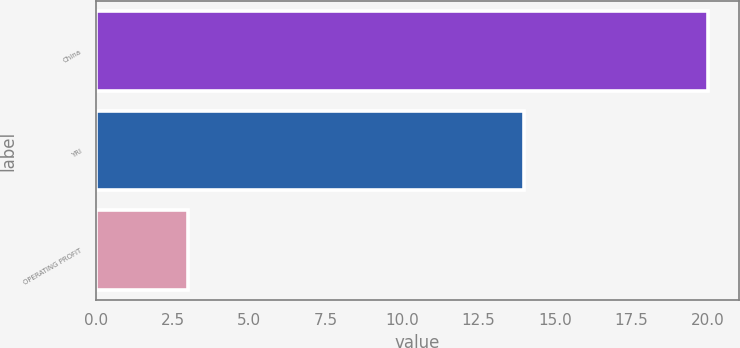<chart> <loc_0><loc_0><loc_500><loc_500><bar_chart><fcel>China<fcel>YRI<fcel>OPERATING PROFIT<nl><fcel>20<fcel>14<fcel>3<nl></chart> 